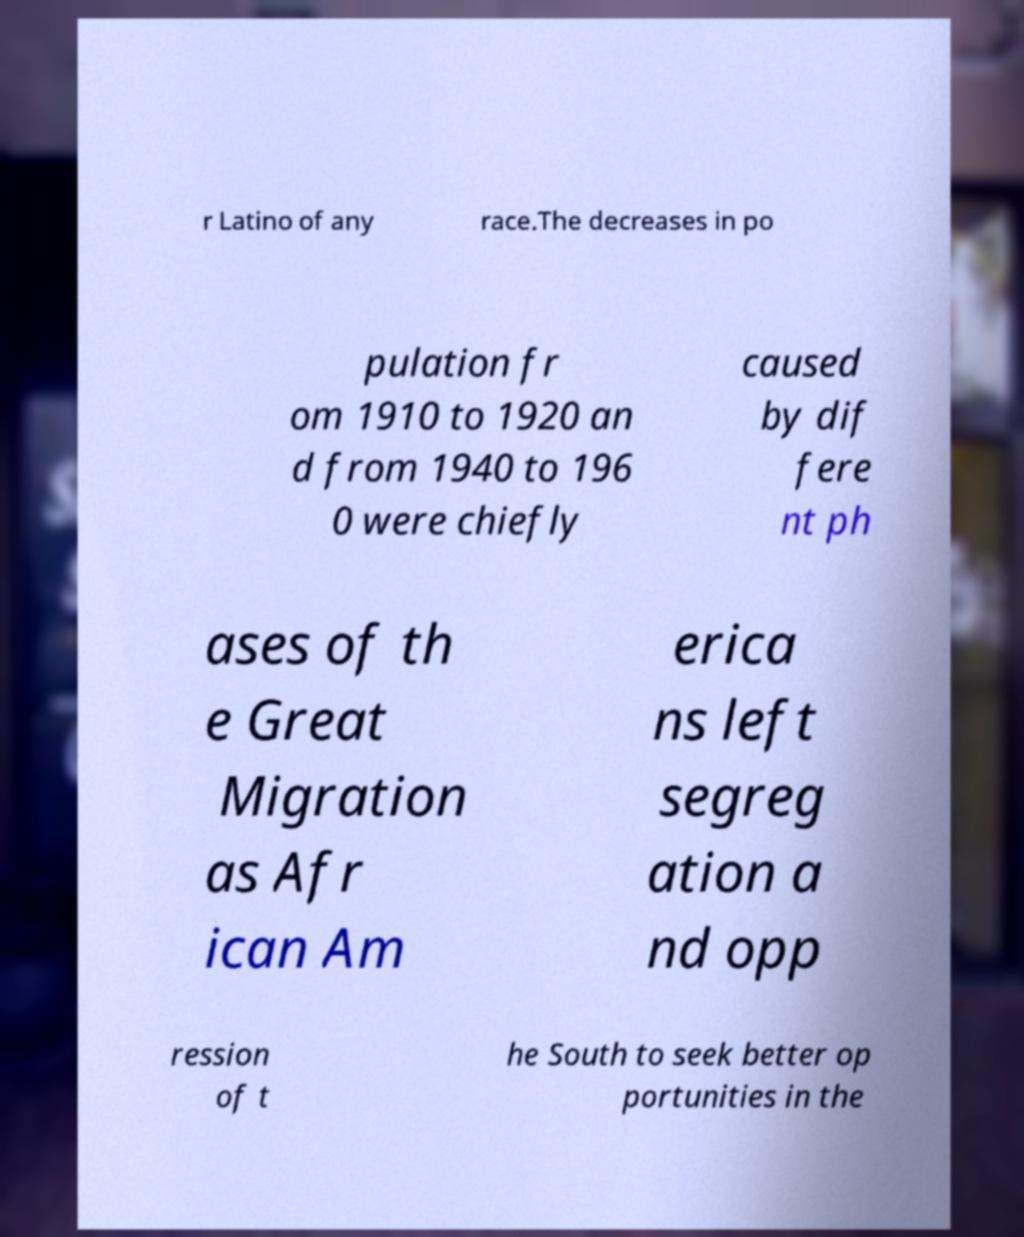Could you assist in decoding the text presented in this image and type it out clearly? r Latino of any race.The decreases in po pulation fr om 1910 to 1920 an d from 1940 to 196 0 were chiefly caused by dif fere nt ph ases of th e Great Migration as Afr ican Am erica ns left segreg ation a nd opp ression of t he South to seek better op portunities in the 